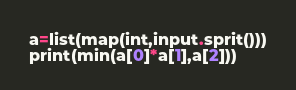<code> <loc_0><loc_0><loc_500><loc_500><_Python_>a=list(map(int,input.sprit()))
print(min(a[0]*a[1],a[2]))</code> 